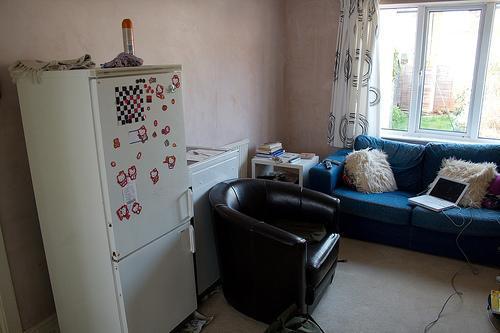How many pillows are on the couch?
Give a very brief answer. 2. 